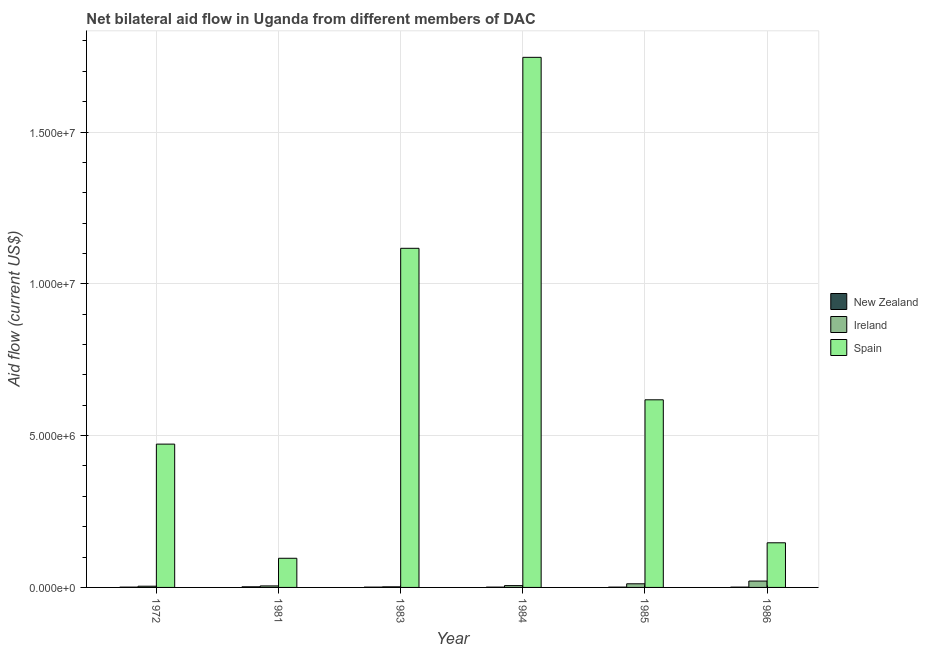How many different coloured bars are there?
Your answer should be very brief. 3. How many groups of bars are there?
Provide a short and direct response. 6. Are the number of bars per tick equal to the number of legend labels?
Your response must be concise. Yes. Are the number of bars on each tick of the X-axis equal?
Ensure brevity in your answer.  Yes. How many bars are there on the 1st tick from the left?
Make the answer very short. 3. What is the label of the 3rd group of bars from the left?
Provide a succinct answer. 1983. In how many cases, is the number of bars for a given year not equal to the number of legend labels?
Give a very brief answer. 0. What is the amount of aid provided by ireland in 1984?
Your answer should be very brief. 6.00e+04. Across all years, what is the maximum amount of aid provided by spain?
Ensure brevity in your answer.  1.75e+07. Across all years, what is the minimum amount of aid provided by new zealand?
Your answer should be very brief. 10000. In which year was the amount of aid provided by ireland minimum?
Offer a terse response. 1983. What is the total amount of aid provided by spain in the graph?
Your answer should be very brief. 4.20e+07. What is the difference between the amount of aid provided by spain in 1983 and that in 1986?
Offer a terse response. 9.70e+06. What is the average amount of aid provided by new zealand per year?
Ensure brevity in your answer.  1.17e+04. What is the ratio of the amount of aid provided by spain in 1972 to that in 1981?
Ensure brevity in your answer.  4.92. Is the difference between the amount of aid provided by ireland in 1981 and 1983 greater than the difference between the amount of aid provided by spain in 1981 and 1983?
Ensure brevity in your answer.  No. What is the difference between the highest and the second highest amount of aid provided by ireland?
Offer a terse response. 9.00e+04. What is the difference between the highest and the lowest amount of aid provided by ireland?
Make the answer very short. 1.90e+05. Is the sum of the amount of aid provided by new zealand in 1972 and 1986 greater than the maximum amount of aid provided by spain across all years?
Provide a short and direct response. No. What does the 2nd bar from the right in 1984 represents?
Your response must be concise. Ireland. Are all the bars in the graph horizontal?
Keep it short and to the point. No. What is the difference between two consecutive major ticks on the Y-axis?
Ensure brevity in your answer.  5.00e+06. Are the values on the major ticks of Y-axis written in scientific E-notation?
Offer a terse response. Yes. Does the graph contain any zero values?
Provide a short and direct response. No. Where does the legend appear in the graph?
Offer a very short reply. Center right. How many legend labels are there?
Make the answer very short. 3. What is the title of the graph?
Keep it short and to the point. Net bilateral aid flow in Uganda from different members of DAC. Does "Coal" appear as one of the legend labels in the graph?
Your response must be concise. No. What is the label or title of the X-axis?
Offer a terse response. Year. What is the label or title of the Y-axis?
Offer a terse response. Aid flow (current US$). What is the Aid flow (current US$) of New Zealand in 1972?
Keep it short and to the point. 10000. What is the Aid flow (current US$) of Spain in 1972?
Keep it short and to the point. 4.72e+06. What is the Aid flow (current US$) of Spain in 1981?
Your answer should be very brief. 9.60e+05. What is the Aid flow (current US$) of Spain in 1983?
Make the answer very short. 1.12e+07. What is the Aid flow (current US$) of New Zealand in 1984?
Make the answer very short. 10000. What is the Aid flow (current US$) in Spain in 1984?
Keep it short and to the point. 1.75e+07. What is the Aid flow (current US$) in Ireland in 1985?
Offer a very short reply. 1.20e+05. What is the Aid flow (current US$) in Spain in 1985?
Your answer should be compact. 6.18e+06. What is the Aid flow (current US$) in New Zealand in 1986?
Your answer should be compact. 10000. What is the Aid flow (current US$) of Spain in 1986?
Give a very brief answer. 1.47e+06. Across all years, what is the maximum Aid flow (current US$) in Ireland?
Give a very brief answer. 2.10e+05. Across all years, what is the maximum Aid flow (current US$) in Spain?
Provide a short and direct response. 1.75e+07. Across all years, what is the minimum Aid flow (current US$) in New Zealand?
Keep it short and to the point. 10000. Across all years, what is the minimum Aid flow (current US$) in Ireland?
Offer a terse response. 2.00e+04. Across all years, what is the minimum Aid flow (current US$) of Spain?
Give a very brief answer. 9.60e+05. What is the total Aid flow (current US$) in Spain in the graph?
Provide a short and direct response. 4.20e+07. What is the difference between the Aid flow (current US$) of Ireland in 1972 and that in 1981?
Ensure brevity in your answer.  -10000. What is the difference between the Aid flow (current US$) in Spain in 1972 and that in 1981?
Make the answer very short. 3.76e+06. What is the difference between the Aid flow (current US$) of New Zealand in 1972 and that in 1983?
Offer a terse response. 0. What is the difference between the Aid flow (current US$) in Ireland in 1972 and that in 1983?
Provide a succinct answer. 2.00e+04. What is the difference between the Aid flow (current US$) of Spain in 1972 and that in 1983?
Your response must be concise. -6.45e+06. What is the difference between the Aid flow (current US$) of New Zealand in 1972 and that in 1984?
Your response must be concise. 0. What is the difference between the Aid flow (current US$) in Ireland in 1972 and that in 1984?
Your answer should be compact. -2.00e+04. What is the difference between the Aid flow (current US$) of Spain in 1972 and that in 1984?
Your answer should be very brief. -1.27e+07. What is the difference between the Aid flow (current US$) in Ireland in 1972 and that in 1985?
Provide a short and direct response. -8.00e+04. What is the difference between the Aid flow (current US$) in Spain in 1972 and that in 1985?
Make the answer very short. -1.46e+06. What is the difference between the Aid flow (current US$) in New Zealand in 1972 and that in 1986?
Provide a short and direct response. 0. What is the difference between the Aid flow (current US$) of Spain in 1972 and that in 1986?
Ensure brevity in your answer.  3.25e+06. What is the difference between the Aid flow (current US$) of New Zealand in 1981 and that in 1983?
Provide a succinct answer. 10000. What is the difference between the Aid flow (current US$) of Ireland in 1981 and that in 1983?
Offer a terse response. 3.00e+04. What is the difference between the Aid flow (current US$) of Spain in 1981 and that in 1983?
Your answer should be very brief. -1.02e+07. What is the difference between the Aid flow (current US$) of Spain in 1981 and that in 1984?
Your answer should be very brief. -1.65e+07. What is the difference between the Aid flow (current US$) in New Zealand in 1981 and that in 1985?
Your answer should be compact. 10000. What is the difference between the Aid flow (current US$) in Ireland in 1981 and that in 1985?
Your answer should be very brief. -7.00e+04. What is the difference between the Aid flow (current US$) of Spain in 1981 and that in 1985?
Provide a short and direct response. -5.22e+06. What is the difference between the Aid flow (current US$) of Spain in 1981 and that in 1986?
Ensure brevity in your answer.  -5.10e+05. What is the difference between the Aid flow (current US$) of Spain in 1983 and that in 1984?
Your answer should be compact. -6.29e+06. What is the difference between the Aid flow (current US$) of Spain in 1983 and that in 1985?
Your answer should be very brief. 4.99e+06. What is the difference between the Aid flow (current US$) in Spain in 1983 and that in 1986?
Your answer should be compact. 9.70e+06. What is the difference between the Aid flow (current US$) of New Zealand in 1984 and that in 1985?
Provide a short and direct response. 0. What is the difference between the Aid flow (current US$) in Ireland in 1984 and that in 1985?
Your answer should be very brief. -6.00e+04. What is the difference between the Aid flow (current US$) of Spain in 1984 and that in 1985?
Offer a very short reply. 1.13e+07. What is the difference between the Aid flow (current US$) in New Zealand in 1984 and that in 1986?
Make the answer very short. 0. What is the difference between the Aid flow (current US$) in Spain in 1984 and that in 1986?
Make the answer very short. 1.60e+07. What is the difference between the Aid flow (current US$) in Ireland in 1985 and that in 1986?
Provide a short and direct response. -9.00e+04. What is the difference between the Aid flow (current US$) of Spain in 1985 and that in 1986?
Your answer should be compact. 4.71e+06. What is the difference between the Aid flow (current US$) of New Zealand in 1972 and the Aid flow (current US$) of Ireland in 1981?
Keep it short and to the point. -4.00e+04. What is the difference between the Aid flow (current US$) of New Zealand in 1972 and the Aid flow (current US$) of Spain in 1981?
Your answer should be very brief. -9.50e+05. What is the difference between the Aid flow (current US$) of Ireland in 1972 and the Aid flow (current US$) of Spain in 1981?
Make the answer very short. -9.20e+05. What is the difference between the Aid flow (current US$) of New Zealand in 1972 and the Aid flow (current US$) of Ireland in 1983?
Offer a very short reply. -10000. What is the difference between the Aid flow (current US$) of New Zealand in 1972 and the Aid flow (current US$) of Spain in 1983?
Provide a succinct answer. -1.12e+07. What is the difference between the Aid flow (current US$) of Ireland in 1972 and the Aid flow (current US$) of Spain in 1983?
Offer a very short reply. -1.11e+07. What is the difference between the Aid flow (current US$) of New Zealand in 1972 and the Aid flow (current US$) of Spain in 1984?
Give a very brief answer. -1.74e+07. What is the difference between the Aid flow (current US$) of Ireland in 1972 and the Aid flow (current US$) of Spain in 1984?
Offer a terse response. -1.74e+07. What is the difference between the Aid flow (current US$) of New Zealand in 1972 and the Aid flow (current US$) of Ireland in 1985?
Provide a succinct answer. -1.10e+05. What is the difference between the Aid flow (current US$) of New Zealand in 1972 and the Aid flow (current US$) of Spain in 1985?
Your answer should be compact. -6.17e+06. What is the difference between the Aid flow (current US$) in Ireland in 1972 and the Aid flow (current US$) in Spain in 1985?
Your answer should be compact. -6.14e+06. What is the difference between the Aid flow (current US$) in New Zealand in 1972 and the Aid flow (current US$) in Ireland in 1986?
Keep it short and to the point. -2.00e+05. What is the difference between the Aid flow (current US$) in New Zealand in 1972 and the Aid flow (current US$) in Spain in 1986?
Provide a short and direct response. -1.46e+06. What is the difference between the Aid flow (current US$) of Ireland in 1972 and the Aid flow (current US$) of Spain in 1986?
Provide a short and direct response. -1.43e+06. What is the difference between the Aid flow (current US$) of New Zealand in 1981 and the Aid flow (current US$) of Ireland in 1983?
Offer a terse response. 0. What is the difference between the Aid flow (current US$) in New Zealand in 1981 and the Aid flow (current US$) in Spain in 1983?
Provide a short and direct response. -1.12e+07. What is the difference between the Aid flow (current US$) of Ireland in 1981 and the Aid flow (current US$) of Spain in 1983?
Make the answer very short. -1.11e+07. What is the difference between the Aid flow (current US$) in New Zealand in 1981 and the Aid flow (current US$) in Ireland in 1984?
Ensure brevity in your answer.  -4.00e+04. What is the difference between the Aid flow (current US$) in New Zealand in 1981 and the Aid flow (current US$) in Spain in 1984?
Your response must be concise. -1.74e+07. What is the difference between the Aid flow (current US$) of Ireland in 1981 and the Aid flow (current US$) of Spain in 1984?
Provide a short and direct response. -1.74e+07. What is the difference between the Aid flow (current US$) in New Zealand in 1981 and the Aid flow (current US$) in Spain in 1985?
Ensure brevity in your answer.  -6.16e+06. What is the difference between the Aid flow (current US$) in Ireland in 1981 and the Aid flow (current US$) in Spain in 1985?
Your answer should be very brief. -6.13e+06. What is the difference between the Aid flow (current US$) in New Zealand in 1981 and the Aid flow (current US$) in Spain in 1986?
Make the answer very short. -1.45e+06. What is the difference between the Aid flow (current US$) in Ireland in 1981 and the Aid flow (current US$) in Spain in 1986?
Give a very brief answer. -1.42e+06. What is the difference between the Aid flow (current US$) of New Zealand in 1983 and the Aid flow (current US$) of Ireland in 1984?
Give a very brief answer. -5.00e+04. What is the difference between the Aid flow (current US$) of New Zealand in 1983 and the Aid flow (current US$) of Spain in 1984?
Ensure brevity in your answer.  -1.74e+07. What is the difference between the Aid flow (current US$) in Ireland in 1983 and the Aid flow (current US$) in Spain in 1984?
Make the answer very short. -1.74e+07. What is the difference between the Aid flow (current US$) in New Zealand in 1983 and the Aid flow (current US$) in Ireland in 1985?
Provide a succinct answer. -1.10e+05. What is the difference between the Aid flow (current US$) of New Zealand in 1983 and the Aid flow (current US$) of Spain in 1985?
Make the answer very short. -6.17e+06. What is the difference between the Aid flow (current US$) in Ireland in 1983 and the Aid flow (current US$) in Spain in 1985?
Offer a terse response. -6.16e+06. What is the difference between the Aid flow (current US$) in New Zealand in 1983 and the Aid flow (current US$) in Ireland in 1986?
Provide a succinct answer. -2.00e+05. What is the difference between the Aid flow (current US$) in New Zealand in 1983 and the Aid flow (current US$) in Spain in 1986?
Offer a very short reply. -1.46e+06. What is the difference between the Aid flow (current US$) of Ireland in 1983 and the Aid flow (current US$) of Spain in 1986?
Keep it short and to the point. -1.45e+06. What is the difference between the Aid flow (current US$) in New Zealand in 1984 and the Aid flow (current US$) in Spain in 1985?
Provide a short and direct response. -6.17e+06. What is the difference between the Aid flow (current US$) of Ireland in 1984 and the Aid flow (current US$) of Spain in 1985?
Make the answer very short. -6.12e+06. What is the difference between the Aid flow (current US$) of New Zealand in 1984 and the Aid flow (current US$) of Spain in 1986?
Your response must be concise. -1.46e+06. What is the difference between the Aid flow (current US$) in Ireland in 1984 and the Aid flow (current US$) in Spain in 1986?
Provide a succinct answer. -1.41e+06. What is the difference between the Aid flow (current US$) of New Zealand in 1985 and the Aid flow (current US$) of Spain in 1986?
Make the answer very short. -1.46e+06. What is the difference between the Aid flow (current US$) of Ireland in 1985 and the Aid flow (current US$) of Spain in 1986?
Ensure brevity in your answer.  -1.35e+06. What is the average Aid flow (current US$) in New Zealand per year?
Make the answer very short. 1.17e+04. What is the average Aid flow (current US$) of Ireland per year?
Offer a terse response. 8.33e+04. What is the average Aid flow (current US$) in Spain per year?
Your answer should be very brief. 6.99e+06. In the year 1972, what is the difference between the Aid flow (current US$) of New Zealand and Aid flow (current US$) of Spain?
Offer a very short reply. -4.71e+06. In the year 1972, what is the difference between the Aid flow (current US$) of Ireland and Aid flow (current US$) of Spain?
Your answer should be compact. -4.68e+06. In the year 1981, what is the difference between the Aid flow (current US$) of New Zealand and Aid flow (current US$) of Spain?
Keep it short and to the point. -9.40e+05. In the year 1981, what is the difference between the Aid flow (current US$) in Ireland and Aid flow (current US$) in Spain?
Give a very brief answer. -9.10e+05. In the year 1983, what is the difference between the Aid flow (current US$) of New Zealand and Aid flow (current US$) of Ireland?
Your answer should be very brief. -10000. In the year 1983, what is the difference between the Aid flow (current US$) in New Zealand and Aid flow (current US$) in Spain?
Provide a short and direct response. -1.12e+07. In the year 1983, what is the difference between the Aid flow (current US$) in Ireland and Aid flow (current US$) in Spain?
Make the answer very short. -1.12e+07. In the year 1984, what is the difference between the Aid flow (current US$) in New Zealand and Aid flow (current US$) in Ireland?
Provide a succinct answer. -5.00e+04. In the year 1984, what is the difference between the Aid flow (current US$) in New Zealand and Aid flow (current US$) in Spain?
Make the answer very short. -1.74e+07. In the year 1984, what is the difference between the Aid flow (current US$) in Ireland and Aid flow (current US$) in Spain?
Ensure brevity in your answer.  -1.74e+07. In the year 1985, what is the difference between the Aid flow (current US$) in New Zealand and Aid flow (current US$) in Spain?
Your answer should be compact. -6.17e+06. In the year 1985, what is the difference between the Aid flow (current US$) of Ireland and Aid flow (current US$) of Spain?
Your response must be concise. -6.06e+06. In the year 1986, what is the difference between the Aid flow (current US$) of New Zealand and Aid flow (current US$) of Ireland?
Your answer should be compact. -2.00e+05. In the year 1986, what is the difference between the Aid flow (current US$) of New Zealand and Aid flow (current US$) of Spain?
Ensure brevity in your answer.  -1.46e+06. In the year 1986, what is the difference between the Aid flow (current US$) of Ireland and Aid flow (current US$) of Spain?
Provide a succinct answer. -1.26e+06. What is the ratio of the Aid flow (current US$) of New Zealand in 1972 to that in 1981?
Your answer should be very brief. 0.5. What is the ratio of the Aid flow (current US$) of Ireland in 1972 to that in 1981?
Give a very brief answer. 0.8. What is the ratio of the Aid flow (current US$) in Spain in 1972 to that in 1981?
Make the answer very short. 4.92. What is the ratio of the Aid flow (current US$) in New Zealand in 1972 to that in 1983?
Provide a short and direct response. 1. What is the ratio of the Aid flow (current US$) in Ireland in 1972 to that in 1983?
Your answer should be very brief. 2. What is the ratio of the Aid flow (current US$) of Spain in 1972 to that in 1983?
Keep it short and to the point. 0.42. What is the ratio of the Aid flow (current US$) of Ireland in 1972 to that in 1984?
Your response must be concise. 0.67. What is the ratio of the Aid flow (current US$) of Spain in 1972 to that in 1984?
Offer a very short reply. 0.27. What is the ratio of the Aid flow (current US$) in Spain in 1972 to that in 1985?
Provide a short and direct response. 0.76. What is the ratio of the Aid flow (current US$) in New Zealand in 1972 to that in 1986?
Keep it short and to the point. 1. What is the ratio of the Aid flow (current US$) in Ireland in 1972 to that in 1986?
Offer a very short reply. 0.19. What is the ratio of the Aid flow (current US$) of Spain in 1972 to that in 1986?
Your answer should be compact. 3.21. What is the ratio of the Aid flow (current US$) of Ireland in 1981 to that in 1983?
Your answer should be compact. 2.5. What is the ratio of the Aid flow (current US$) in Spain in 1981 to that in 1983?
Your answer should be compact. 0.09. What is the ratio of the Aid flow (current US$) in New Zealand in 1981 to that in 1984?
Offer a terse response. 2. What is the ratio of the Aid flow (current US$) in Ireland in 1981 to that in 1984?
Offer a terse response. 0.83. What is the ratio of the Aid flow (current US$) of Spain in 1981 to that in 1984?
Give a very brief answer. 0.06. What is the ratio of the Aid flow (current US$) of New Zealand in 1981 to that in 1985?
Your answer should be compact. 2. What is the ratio of the Aid flow (current US$) in Ireland in 1981 to that in 1985?
Your response must be concise. 0.42. What is the ratio of the Aid flow (current US$) of Spain in 1981 to that in 1985?
Provide a short and direct response. 0.16. What is the ratio of the Aid flow (current US$) in Ireland in 1981 to that in 1986?
Your response must be concise. 0.24. What is the ratio of the Aid flow (current US$) of Spain in 1981 to that in 1986?
Offer a very short reply. 0.65. What is the ratio of the Aid flow (current US$) in New Zealand in 1983 to that in 1984?
Give a very brief answer. 1. What is the ratio of the Aid flow (current US$) in Ireland in 1983 to that in 1984?
Ensure brevity in your answer.  0.33. What is the ratio of the Aid flow (current US$) of Spain in 1983 to that in 1984?
Your answer should be compact. 0.64. What is the ratio of the Aid flow (current US$) of New Zealand in 1983 to that in 1985?
Provide a succinct answer. 1. What is the ratio of the Aid flow (current US$) in Spain in 1983 to that in 1985?
Offer a terse response. 1.81. What is the ratio of the Aid flow (current US$) of Ireland in 1983 to that in 1986?
Make the answer very short. 0.1. What is the ratio of the Aid flow (current US$) in Spain in 1983 to that in 1986?
Provide a short and direct response. 7.6. What is the ratio of the Aid flow (current US$) of New Zealand in 1984 to that in 1985?
Your response must be concise. 1. What is the ratio of the Aid flow (current US$) of Ireland in 1984 to that in 1985?
Ensure brevity in your answer.  0.5. What is the ratio of the Aid flow (current US$) of Spain in 1984 to that in 1985?
Your answer should be compact. 2.83. What is the ratio of the Aid flow (current US$) in New Zealand in 1984 to that in 1986?
Your answer should be very brief. 1. What is the ratio of the Aid flow (current US$) of Ireland in 1984 to that in 1986?
Provide a succinct answer. 0.29. What is the ratio of the Aid flow (current US$) in Spain in 1984 to that in 1986?
Provide a succinct answer. 11.88. What is the ratio of the Aid flow (current US$) of Ireland in 1985 to that in 1986?
Keep it short and to the point. 0.57. What is the ratio of the Aid flow (current US$) in Spain in 1985 to that in 1986?
Offer a very short reply. 4.2. What is the difference between the highest and the second highest Aid flow (current US$) in Spain?
Your answer should be very brief. 6.29e+06. What is the difference between the highest and the lowest Aid flow (current US$) in New Zealand?
Ensure brevity in your answer.  10000. What is the difference between the highest and the lowest Aid flow (current US$) in Ireland?
Give a very brief answer. 1.90e+05. What is the difference between the highest and the lowest Aid flow (current US$) in Spain?
Ensure brevity in your answer.  1.65e+07. 